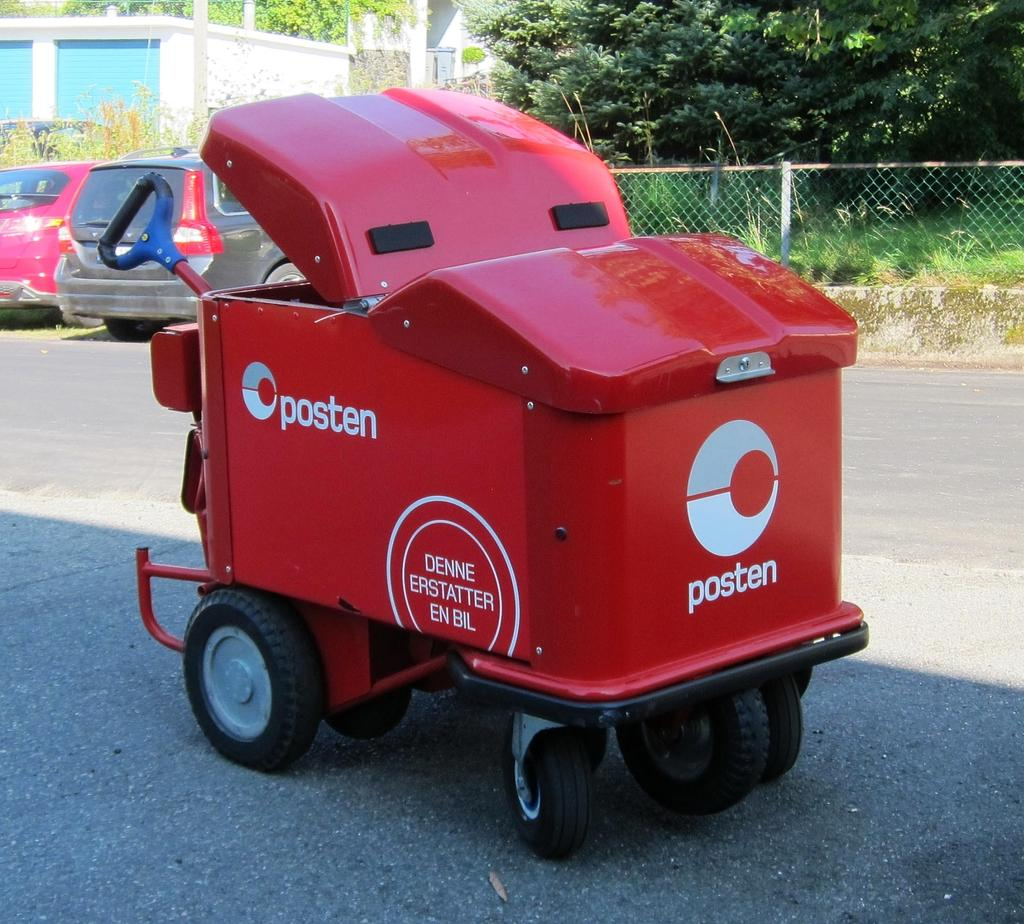What color is the vehicle on the road in the image? The vehicle on the road is red. Can you describe the surroundings of the vehicle? There are other vehicles on the road, fencing, trees, and a building visible in the image. What type of structure can be seen in the image? There is a building in the image. Can you tell me how many dogs are sitting on the cactus in the image? There are no dogs or cacti present in the image. 